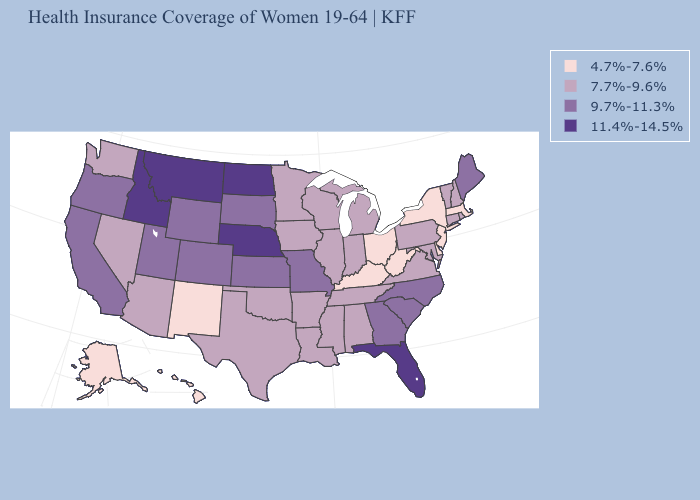Does Delaware have the same value as Utah?
Give a very brief answer. No. Name the states that have a value in the range 4.7%-7.6%?
Concise answer only. Alaska, Delaware, Hawaii, Kentucky, Massachusetts, New Jersey, New Mexico, New York, Ohio, West Virginia. Name the states that have a value in the range 7.7%-9.6%?
Write a very short answer. Alabama, Arizona, Arkansas, Connecticut, Illinois, Indiana, Iowa, Louisiana, Maryland, Michigan, Minnesota, Mississippi, Nevada, New Hampshire, Oklahoma, Pennsylvania, Rhode Island, Tennessee, Texas, Vermont, Virginia, Washington, Wisconsin. Name the states that have a value in the range 11.4%-14.5%?
Be succinct. Florida, Idaho, Montana, Nebraska, North Dakota. What is the highest value in the USA?
Quick response, please. 11.4%-14.5%. What is the value of Maine?
Write a very short answer. 9.7%-11.3%. Which states have the lowest value in the South?
Concise answer only. Delaware, Kentucky, West Virginia. What is the value of West Virginia?
Give a very brief answer. 4.7%-7.6%. Does the map have missing data?
Short answer required. No. Does Indiana have the lowest value in the USA?
Be succinct. No. Does Arizona have the lowest value in the USA?
Quick response, please. No. Which states have the lowest value in the MidWest?
Be succinct. Ohio. What is the highest value in states that border Arizona?
Quick response, please. 9.7%-11.3%. Does Florida have the highest value in the South?
Short answer required. Yes. Name the states that have a value in the range 4.7%-7.6%?
Write a very short answer. Alaska, Delaware, Hawaii, Kentucky, Massachusetts, New Jersey, New Mexico, New York, Ohio, West Virginia. 